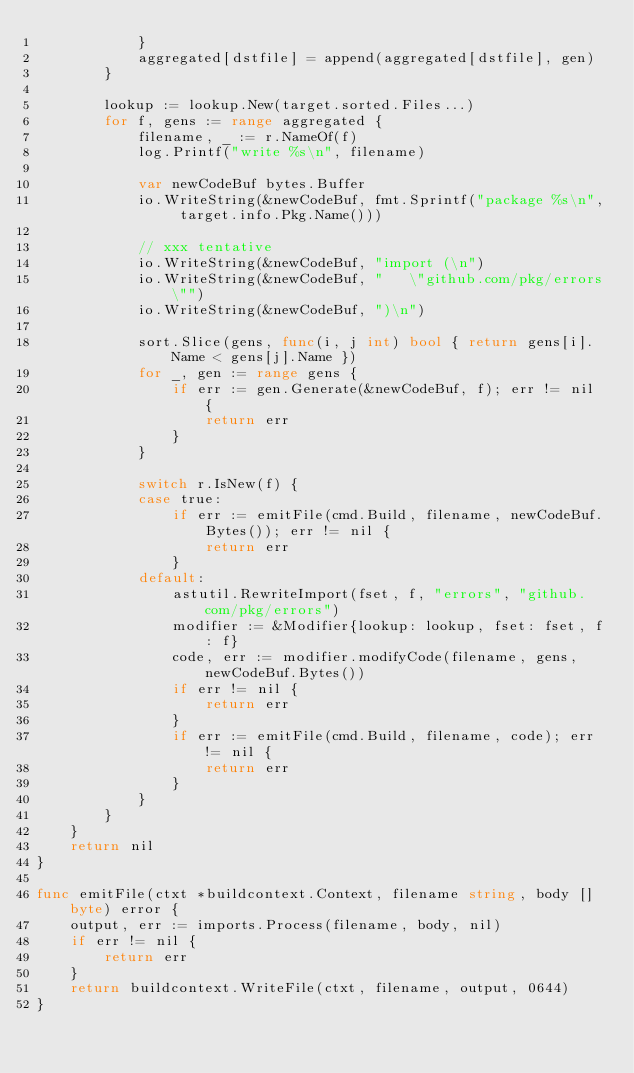<code> <loc_0><loc_0><loc_500><loc_500><_Go_>			}
			aggregated[dstfile] = append(aggregated[dstfile], gen)
		}

		lookup := lookup.New(target.sorted.Files...)
		for f, gens := range aggregated {
			filename, _ := r.NameOf(f)
			log.Printf("write %s\n", filename)

			var newCodeBuf bytes.Buffer
			io.WriteString(&newCodeBuf, fmt.Sprintf("package %s\n", target.info.Pkg.Name()))

			// xxx tentative
			io.WriteString(&newCodeBuf, "import (\n")
			io.WriteString(&newCodeBuf, "	\"github.com/pkg/errors\"")
			io.WriteString(&newCodeBuf, ")\n")

			sort.Slice(gens, func(i, j int) bool { return gens[i].Name < gens[j].Name })
			for _, gen := range gens {
				if err := gen.Generate(&newCodeBuf, f); err != nil {
					return err
				}
			}

			switch r.IsNew(f) {
			case true:
				if err := emitFile(cmd.Build, filename, newCodeBuf.Bytes()); err != nil {
					return err
				}
			default:
				astutil.RewriteImport(fset, f, "errors", "github.com/pkg/errors")
				modifier := &Modifier{lookup: lookup, fset: fset, f: f}
				code, err := modifier.modifyCode(filename, gens, newCodeBuf.Bytes())
				if err != nil {
					return err
				}
				if err := emitFile(cmd.Build, filename, code); err != nil {
					return err
				}
			}
		}
	}
	return nil
}

func emitFile(ctxt *buildcontext.Context, filename string, body []byte) error {
	output, err := imports.Process(filename, body, nil)
	if err != nil {
		return err
	}
	return buildcontext.WriteFile(ctxt, filename, output, 0644)
}
</code> 